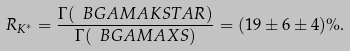Convert formula to latex. <formula><loc_0><loc_0><loc_500><loc_500>R _ { K ^ { * } } = \frac { \Gamma ( \ B G A M A K S T A R ) } { \Gamma ( \ B G A M A X S ) } = ( 1 9 \pm 6 \pm 4 ) \% .</formula> 